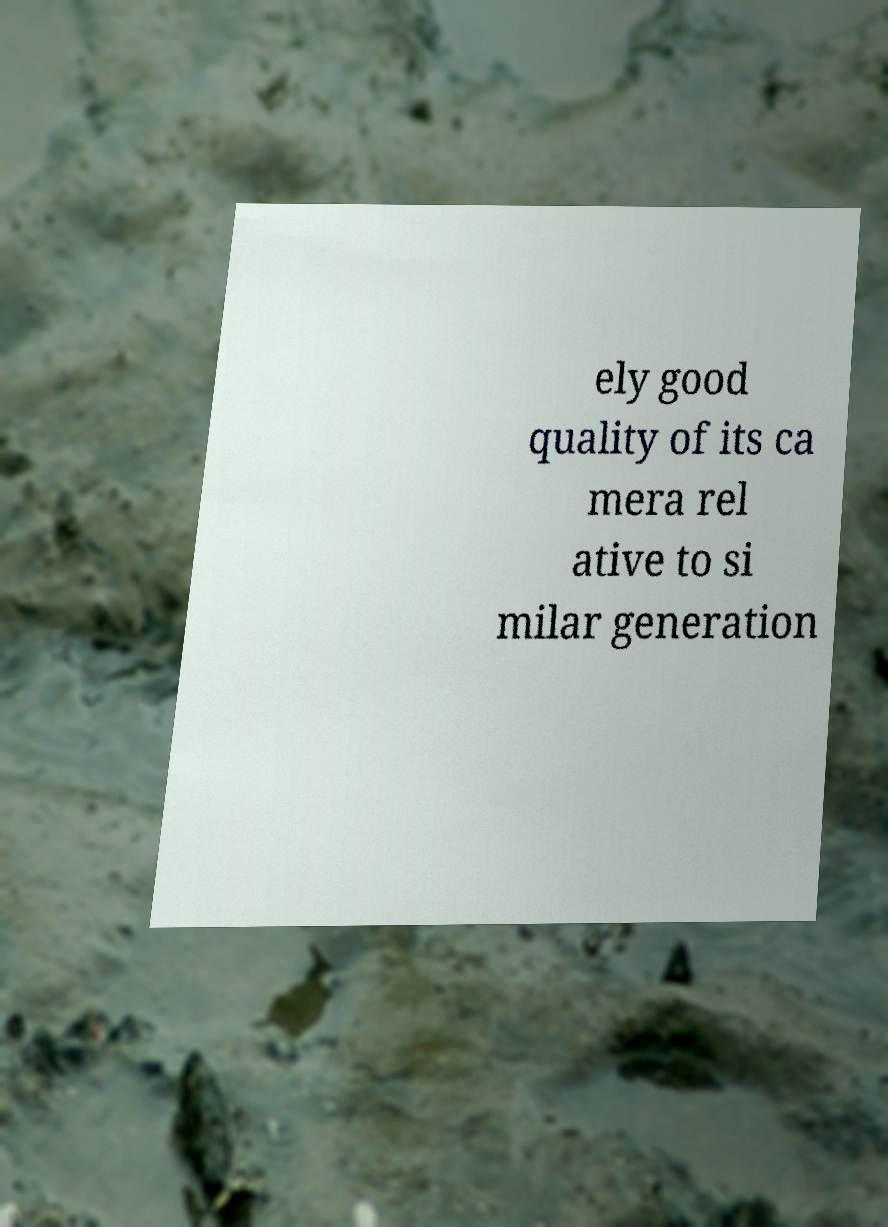For documentation purposes, I need the text within this image transcribed. Could you provide that? ely good quality of its ca mera rel ative to si milar generation 